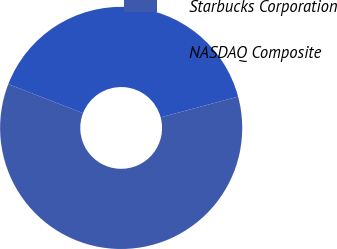Convert chart. <chart><loc_0><loc_0><loc_500><loc_500><pie_chart><fcel>Starbucks Corporation<fcel>NASDAQ Composite<nl><fcel>60.06%<fcel>39.94%<nl></chart> 